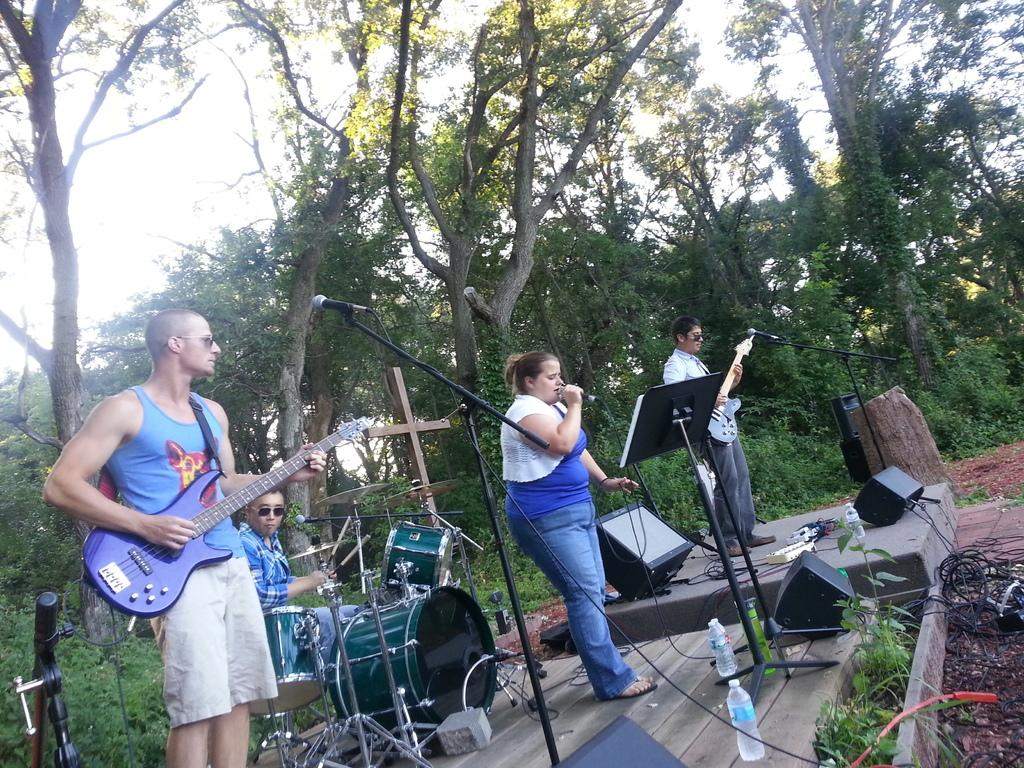What are the two persons in the image doing? The two persons in the image are playing guitar. What is the person on the microphone doing? The person on the microphone is singing. What other objects related to music can be seen in the image? There are musical instruments in the image. What can be seen in the background of the image? There are trees and the sky visible in the background of the image. What type of lunchroom can be seen in the image? There is no lunchroom present in the image. Can you hear the thunder in the background of the image? There is no mention of thunder in the image, and it is not possible to hear sounds through a visual medium. 